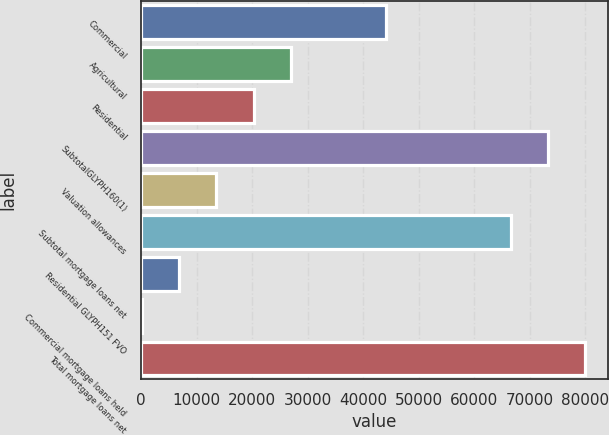Convert chart to OTSL. <chart><loc_0><loc_0><loc_500><loc_500><bar_chart><fcel>Commercial<fcel>Agricultural<fcel>Residential<fcel>SubtotalGLYPH160(1)<fcel>Valuation allowances<fcel>Subtotal mortgage loans net<fcel>Residential GLYPH151 FVO<fcel>Commercial mortgage loans held<fcel>Total mortgage loans net<nl><fcel>44012<fcel>26944<fcel>20251<fcel>73309<fcel>13558<fcel>66616<fcel>6865<fcel>172<fcel>80002<nl></chart> 